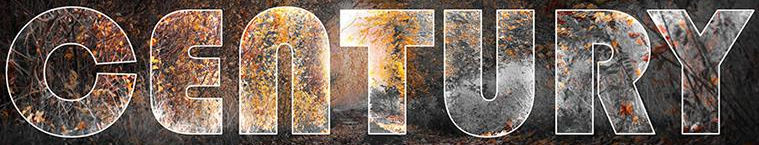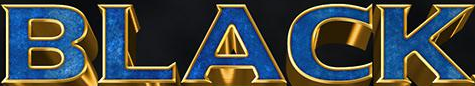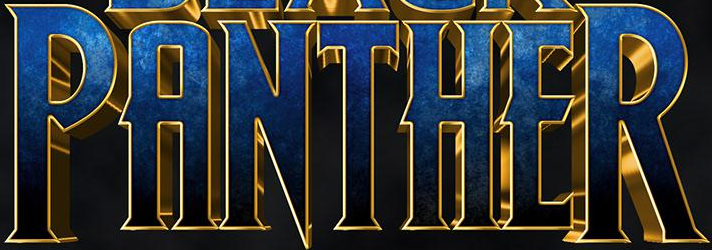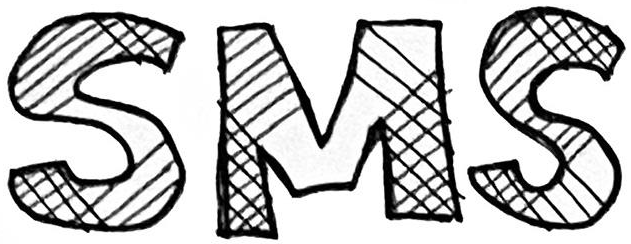What text appears in these images from left to right, separated by a semicolon? CENTURY; BLACK; PANTHER; SMS 